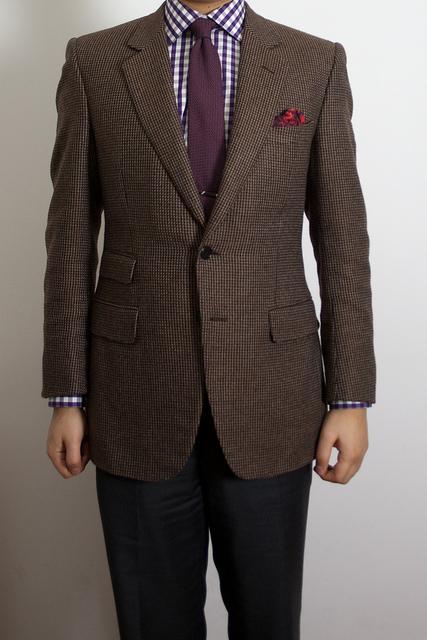Does this outfit look sloppy?
Be succinct. No. Is this a shop window dummy?
Be succinct. No. Does this tie have a pattern?
Be succinct. No. What color is the tie?
Concise answer only. Purple. What is in the man's suit coat pocket?
Be succinct. Handkerchief. 